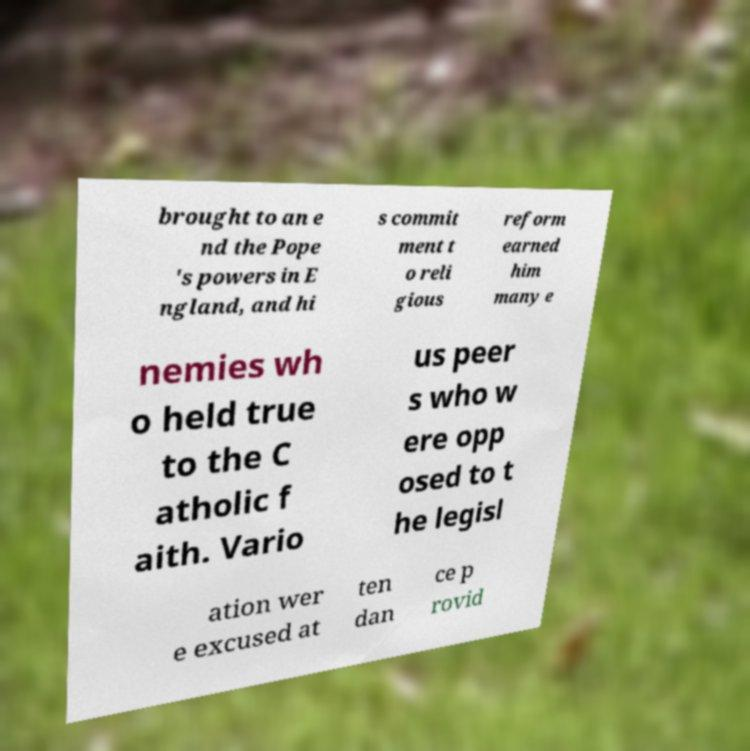Could you assist in decoding the text presented in this image and type it out clearly? brought to an e nd the Pope 's powers in E ngland, and hi s commit ment t o reli gious reform earned him many e nemies wh o held true to the C atholic f aith. Vario us peer s who w ere opp osed to t he legisl ation wer e excused at ten dan ce p rovid 